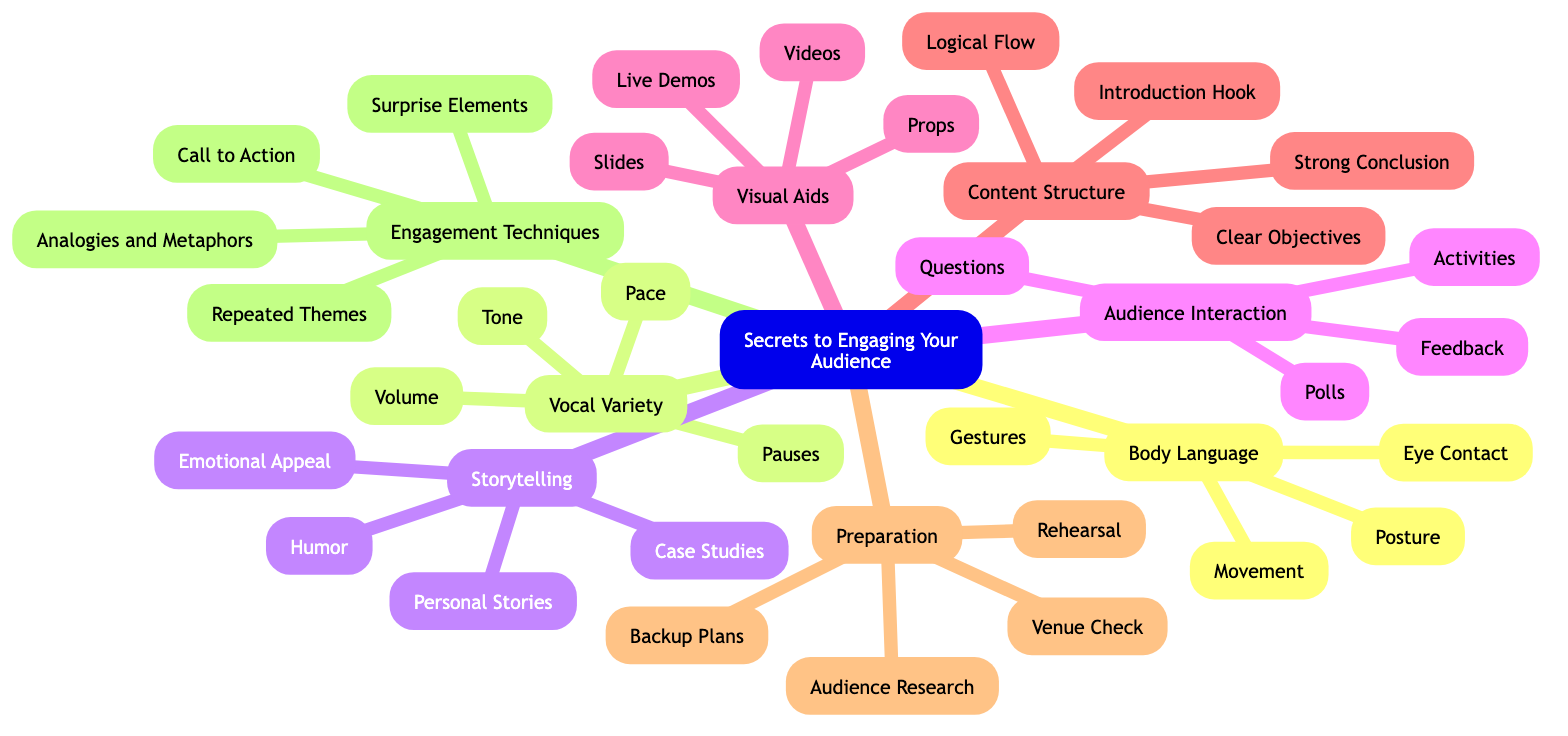What are the main topics in the mind map? The mind map contains several main topics: Body Language, Vocal Variety, Storytelling, Audience Interaction, Visual Aids, Content Structure, Preparation, and Engagement Techniques.
Answer: Body Language, Vocal Variety, Storytelling, Audience Interaction, Visual Aids, Content Structure, Preparation, Engagement Techniques How many subtopics are under Storytelling? Under the Storytelling topic, there are four subtopics: Personal Stories, Case Studies, Humor, and Emotional Appeal. The count leads to the conclusion.
Answer: 4 What is one technique listed under Vocal Variety? The Vocal Variety topic lists several techniques, one of which is Tone. Identifying any one technique suffices to answer the question.
Answer: Tone Which topic includes engaging questions as a subtopic? The Audience Interaction topic comprises engaging questions as one of its subtopics, indicating the focus on interaction strategies.
Answer: Audience Interaction What are the four main elements of Body Language? The Body Language category includes Eye Contact, Gestures, Posture, and Movement as its four sub-elements. Recognizing these will yield the answer.
Answer: Eye Contact, Gestures, Posture, Movement How many main elements are listed under Preparation? The Preparation topic outlines four main elements: Rehearsal, Audience Research, Venue Check, and Backup Plans. By counting them, we derive the answer.
Answer: 4 What do Surprise Elements aim to achieve in the context of engagement? Surprise Elements aim to keep the audience alert, serving as a technique to enhance audience engagement. By examining the context of the element, we confirm its purpose.
Answer: Keep the audience alert What is the purpose of using Pauses in Vocal Variety? The purpose of Pauses in Vocal Variety is to create strategic silences for emphasis, crucial for maintaining audience interest. This understanding blends the element's goal with its application.
Answer: Strategic silences for emphasis What conclusion can be drawn about the relationship between Content Structure and Audience Engagement? Content Structure plays a crucial role in engaging the audience by ensuring a logical flow and strong conclusion, demonstrating the connection between structure and audience interest. This reasoning requires combining elements.
Answer: Logical flow and strong conclusion 